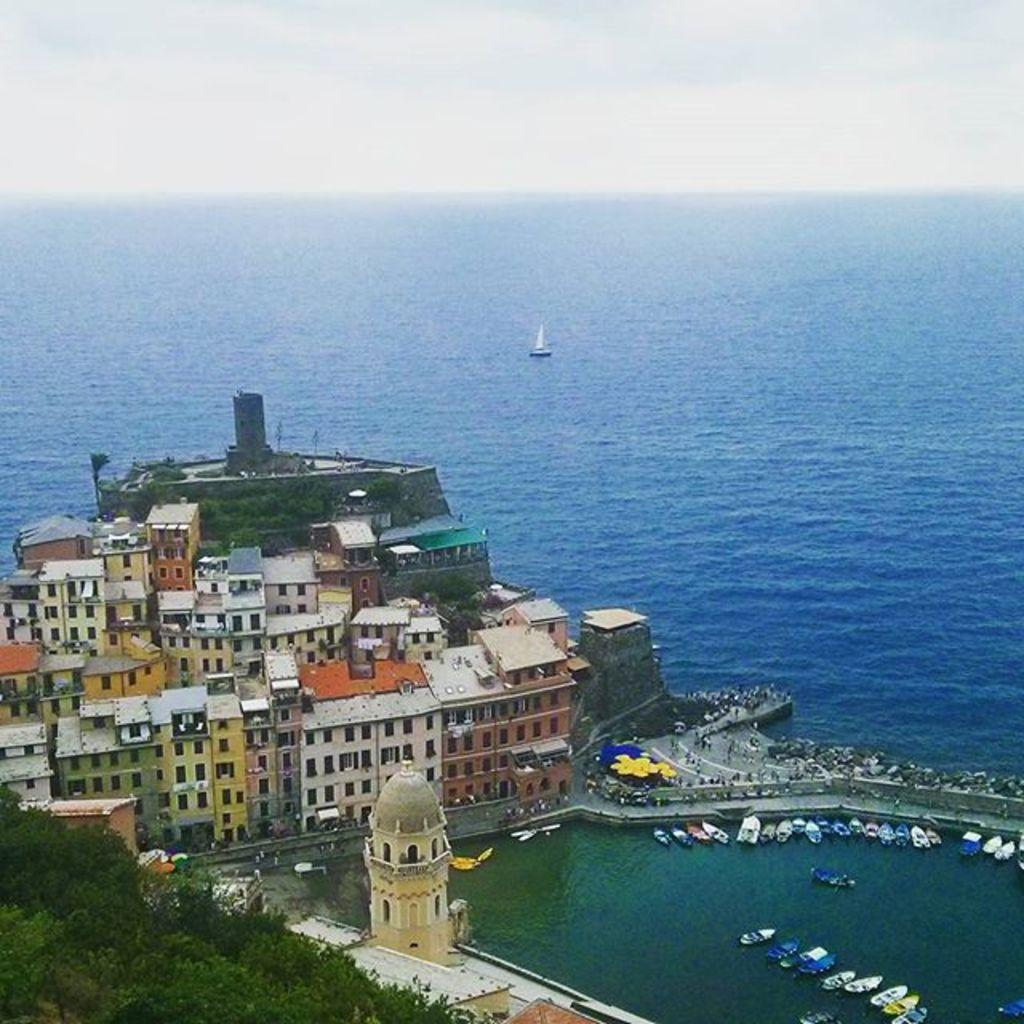What type of structures can be seen in the image? There are buildings in the image. What other natural elements are present in the image? There are trees in the image. What can be seen on the water in the image? There are boats on the water in the image. What is visible in the background of the image? The sky is visible in the background of the image. What type of bushes can be seen in the image? There are no bushes present in the image. What topic is being discussed in the image? There is no discussion taking place in the image; it is a static scene featuring buildings, trees, boats, and the sky. 